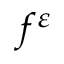<formula> <loc_0><loc_0><loc_500><loc_500>f ^ { \varepsilon }</formula> 